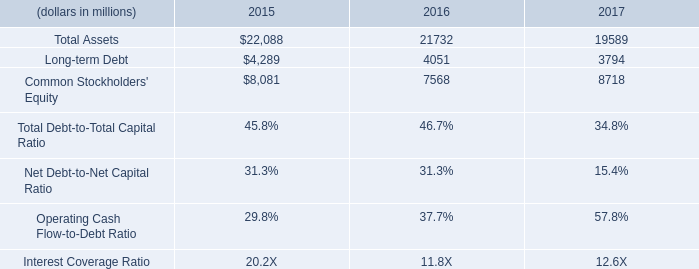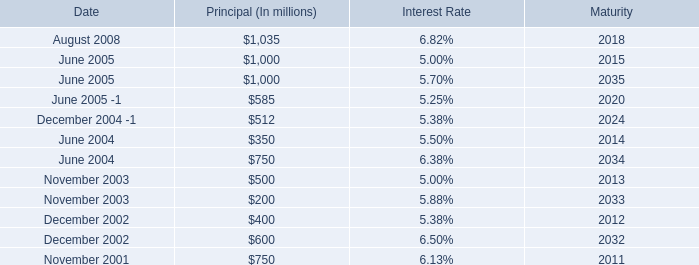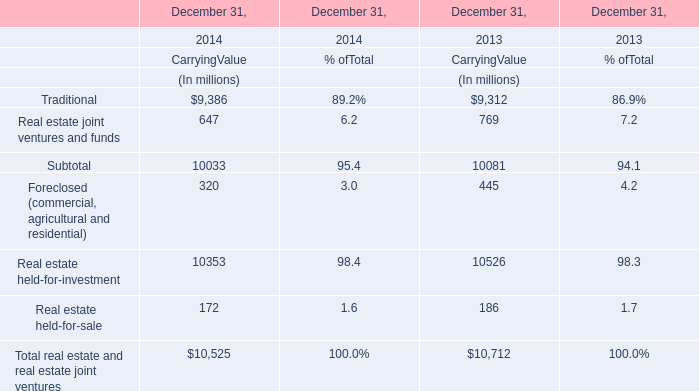what percentage of total debt was long-term debt in 2017? 
Computations: (3794 / (4.7 * 1000))
Answer: 0.80723. 